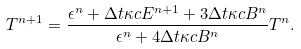<formula> <loc_0><loc_0><loc_500><loc_500>T ^ { n + 1 } = \frac { \epsilon ^ { n } + \Delta t \kappa c E ^ { n + 1 } + 3 \Delta t \kappa c B ^ { n } } { \epsilon ^ { n } + 4 \Delta t \kappa c B ^ { n } } T ^ { n } .</formula> 